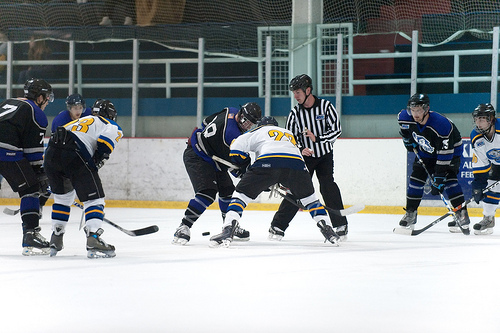<image>
Can you confirm if the man one is in front of the referee? No. The man one is not in front of the referee. The spatial positioning shows a different relationship between these objects. 